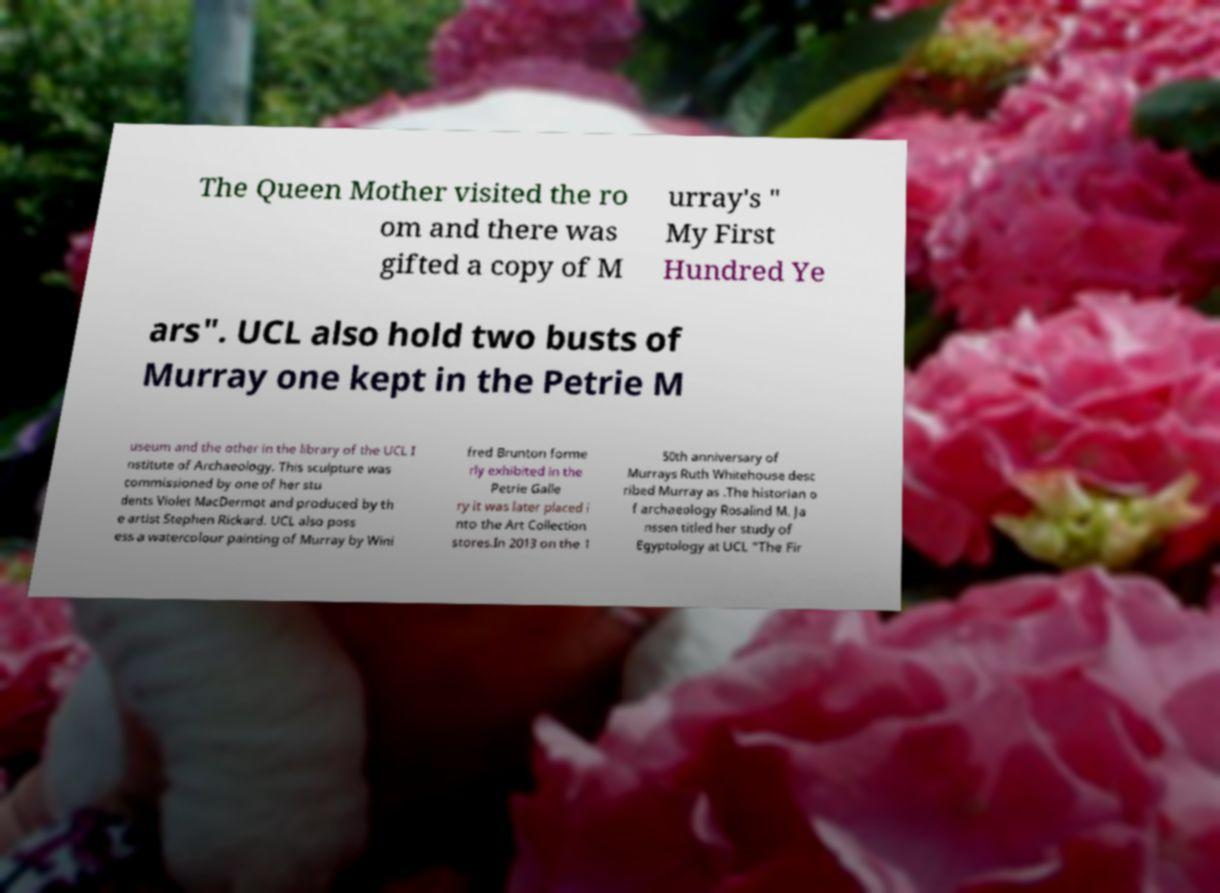I need the written content from this picture converted into text. Can you do that? The Queen Mother visited the ro om and there was gifted a copy of M urray's " My First Hundred Ye ars". UCL also hold two busts of Murray one kept in the Petrie M useum and the other in the library of the UCL I nstitute of Archaeology. This sculpture was commissioned by one of her stu dents Violet MacDermot and produced by th e artist Stephen Rickard. UCL also poss ess a watercolour painting of Murray by Wini fred Brunton forme rly exhibited in the Petrie Galle ry it was later placed i nto the Art Collection stores.In 2013 on the 1 50th anniversary of Murrays Ruth Whitehouse desc ribed Murray as .The historian o f archaeology Rosalind M. Ja nssen titled her study of Egyptology at UCL "The Fir 